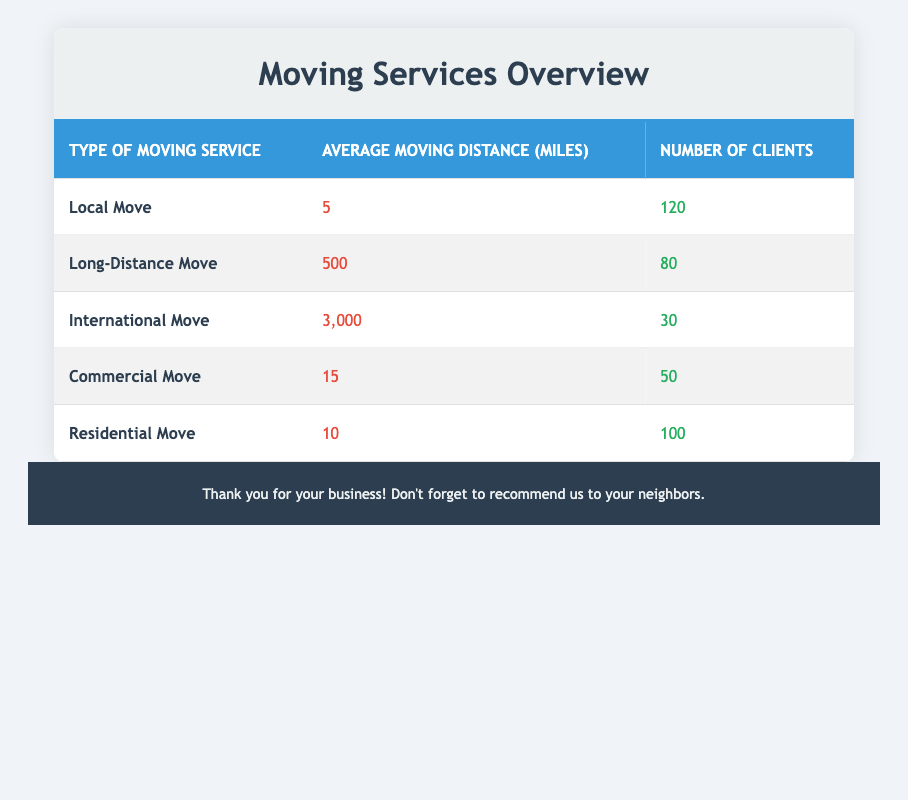What's the average moving distance for a Local Move? According to the table, the average moving distance for a Local Move is stated directly as 5 miles.
Answer: 5 miles How many clients opted for the International Move service? The table provides the number of clients for each moving service, and for the International Move, it specifically states there are 30 clients.
Answer: 30 clients Which type of moving service has the highest average moving distance? By comparing the average moving distances listed for each service, the International Move has the highest average at 3000 miles, compared to 500 miles for Long-Distance Move and lower distances for the other services.
Answer: International Move What is the total number of clients for Local and Residential Moves combined? To find the combined total, add the number of clients for Local Move (120) and Residential Move (100). This sums to 120 + 100 = 220.
Answer: 220 clients Is the average moving distance for a Commercial Move greater than that for a Local Move? The average moving distance for Commercial Move is 15 miles, which is indeed greater than the 5 miles for Local Move. Therefore, the statement is true.
Answer: Yes What is the average number of clients across all types of moving services? First, add the number of clients for all services: 120 (Local) + 80 (Long-Distance) + 30 (International) + 50 (Commercial) + 100 (Residential) = 380 clients total. Then, divide by the number of service types (5) to get the average: 380 / 5 = 76.
Answer: 76 clients Is the number of clients for Long-Distance Moves lower than that for Commercial Moves? The table indicates that Long-Distance Moves have 80 clients, while Commercial Moves have 50 clients. Since 80 is greater than 50, the statement is false.
Answer: No Which type of moving service requires the greatest average distance to be traveled compared to the average distance of a Residential Move? The average moving distance for Residential Move is 10 miles. Comparing it with other services, the Long-Distance Move is significantly greater at 500 miles and the International Move at 3000 miles. Therefore, both Long-Distance and International Moves require a greater distance.
Answer: Yes, both Long-Distance Move and International Move are greater 